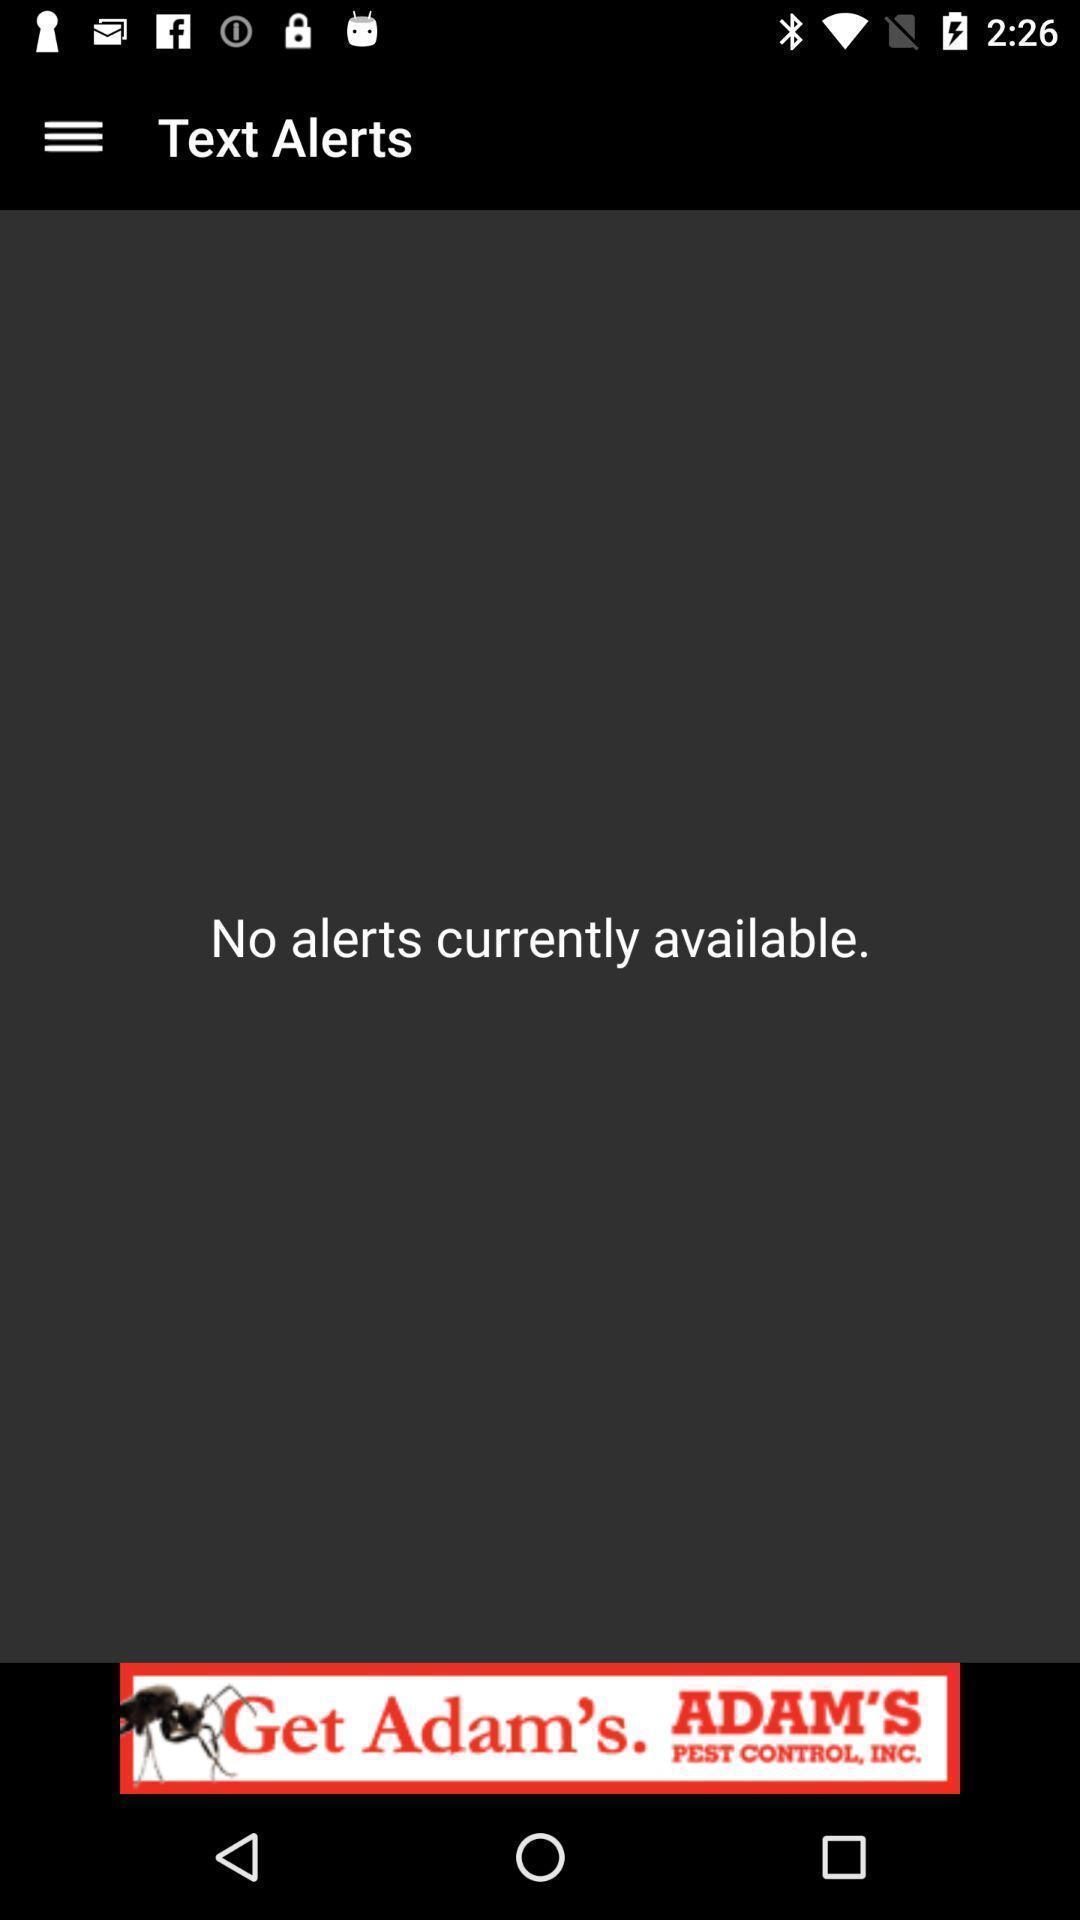Describe the visual elements of this screenshot. Text alerts page. 